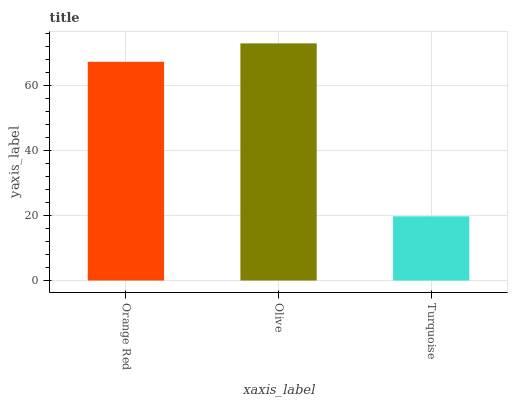Is Olive the minimum?
Answer yes or no. No. Is Turquoise the maximum?
Answer yes or no. No. Is Olive greater than Turquoise?
Answer yes or no. Yes. Is Turquoise less than Olive?
Answer yes or no. Yes. Is Turquoise greater than Olive?
Answer yes or no. No. Is Olive less than Turquoise?
Answer yes or no. No. Is Orange Red the high median?
Answer yes or no. Yes. Is Orange Red the low median?
Answer yes or no. Yes. Is Turquoise the high median?
Answer yes or no. No. Is Olive the low median?
Answer yes or no. No. 